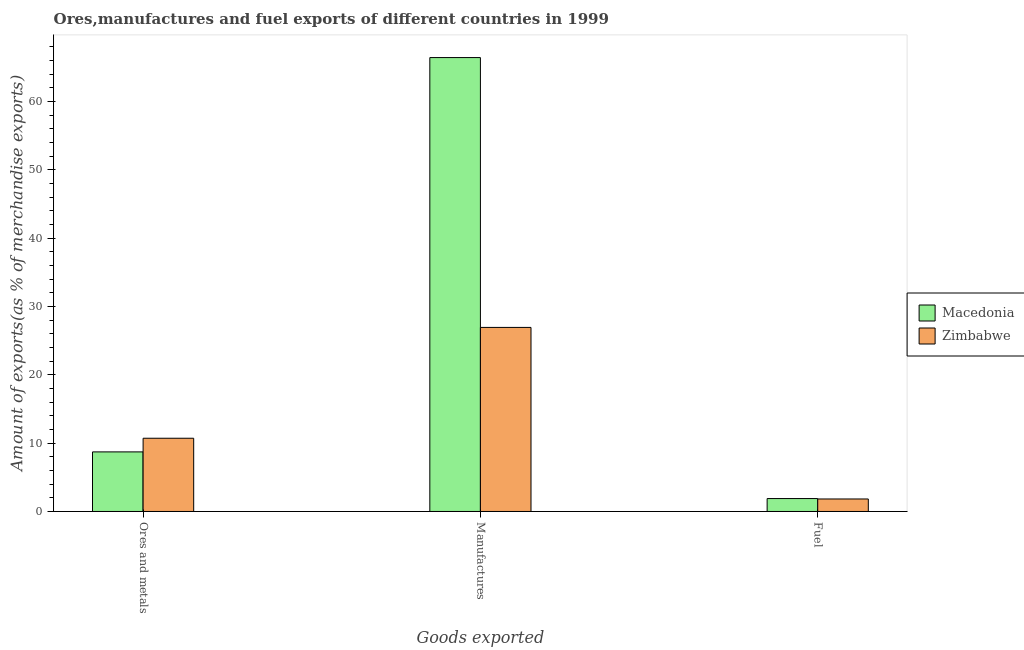How many different coloured bars are there?
Make the answer very short. 2. How many groups of bars are there?
Give a very brief answer. 3. Are the number of bars per tick equal to the number of legend labels?
Provide a short and direct response. Yes. How many bars are there on the 2nd tick from the left?
Offer a terse response. 2. How many bars are there on the 2nd tick from the right?
Provide a short and direct response. 2. What is the label of the 3rd group of bars from the left?
Provide a short and direct response. Fuel. What is the percentage of manufactures exports in Macedonia?
Provide a succinct answer. 66.43. Across all countries, what is the maximum percentage of fuel exports?
Ensure brevity in your answer.  1.89. Across all countries, what is the minimum percentage of manufactures exports?
Your answer should be very brief. 26.94. In which country was the percentage of manufactures exports maximum?
Your response must be concise. Macedonia. In which country was the percentage of manufactures exports minimum?
Your answer should be compact. Zimbabwe. What is the total percentage of fuel exports in the graph?
Your response must be concise. 3.72. What is the difference between the percentage of ores and metals exports in Macedonia and that in Zimbabwe?
Make the answer very short. -2. What is the difference between the percentage of ores and metals exports in Macedonia and the percentage of manufactures exports in Zimbabwe?
Provide a short and direct response. -18.22. What is the average percentage of fuel exports per country?
Offer a terse response. 1.86. What is the difference between the percentage of fuel exports and percentage of ores and metals exports in Zimbabwe?
Your answer should be compact. -8.89. What is the ratio of the percentage of ores and metals exports in Macedonia to that in Zimbabwe?
Provide a succinct answer. 0.81. Is the difference between the percentage of manufactures exports in Zimbabwe and Macedonia greater than the difference between the percentage of ores and metals exports in Zimbabwe and Macedonia?
Your answer should be compact. No. What is the difference between the highest and the second highest percentage of manufactures exports?
Provide a succinct answer. 39.49. What is the difference between the highest and the lowest percentage of ores and metals exports?
Provide a succinct answer. 2. What does the 1st bar from the left in Ores and metals represents?
Keep it short and to the point. Macedonia. What does the 2nd bar from the right in Manufactures represents?
Your answer should be very brief. Macedonia. Is it the case that in every country, the sum of the percentage of ores and metals exports and percentage of manufactures exports is greater than the percentage of fuel exports?
Give a very brief answer. Yes. How many bars are there?
Your answer should be compact. 6. Are all the bars in the graph horizontal?
Make the answer very short. No. What is the difference between two consecutive major ticks on the Y-axis?
Your answer should be very brief. 10. Are the values on the major ticks of Y-axis written in scientific E-notation?
Your answer should be compact. No. Does the graph contain grids?
Offer a terse response. No. How many legend labels are there?
Make the answer very short. 2. What is the title of the graph?
Your answer should be very brief. Ores,manufactures and fuel exports of different countries in 1999. What is the label or title of the X-axis?
Make the answer very short. Goods exported. What is the label or title of the Y-axis?
Provide a succinct answer. Amount of exports(as % of merchandise exports). What is the Amount of exports(as % of merchandise exports) in Macedonia in Ores and metals?
Provide a short and direct response. 8.72. What is the Amount of exports(as % of merchandise exports) of Zimbabwe in Ores and metals?
Provide a succinct answer. 10.72. What is the Amount of exports(as % of merchandise exports) of Macedonia in Manufactures?
Make the answer very short. 66.43. What is the Amount of exports(as % of merchandise exports) of Zimbabwe in Manufactures?
Offer a very short reply. 26.94. What is the Amount of exports(as % of merchandise exports) in Macedonia in Fuel?
Your answer should be compact. 1.89. What is the Amount of exports(as % of merchandise exports) in Zimbabwe in Fuel?
Offer a terse response. 1.83. Across all Goods exported, what is the maximum Amount of exports(as % of merchandise exports) of Macedonia?
Offer a terse response. 66.43. Across all Goods exported, what is the maximum Amount of exports(as % of merchandise exports) in Zimbabwe?
Ensure brevity in your answer.  26.94. Across all Goods exported, what is the minimum Amount of exports(as % of merchandise exports) of Macedonia?
Your answer should be compact. 1.89. Across all Goods exported, what is the minimum Amount of exports(as % of merchandise exports) in Zimbabwe?
Your response must be concise. 1.83. What is the total Amount of exports(as % of merchandise exports) of Macedonia in the graph?
Provide a short and direct response. 77.04. What is the total Amount of exports(as % of merchandise exports) in Zimbabwe in the graph?
Offer a very short reply. 39.49. What is the difference between the Amount of exports(as % of merchandise exports) of Macedonia in Ores and metals and that in Manufactures?
Offer a terse response. -57.71. What is the difference between the Amount of exports(as % of merchandise exports) of Zimbabwe in Ores and metals and that in Manufactures?
Your answer should be very brief. -16.22. What is the difference between the Amount of exports(as % of merchandise exports) in Macedonia in Ores and metals and that in Fuel?
Your answer should be very brief. 6.83. What is the difference between the Amount of exports(as % of merchandise exports) of Zimbabwe in Ores and metals and that in Fuel?
Your answer should be compact. 8.89. What is the difference between the Amount of exports(as % of merchandise exports) of Macedonia in Manufactures and that in Fuel?
Keep it short and to the point. 64.54. What is the difference between the Amount of exports(as % of merchandise exports) of Zimbabwe in Manufactures and that in Fuel?
Keep it short and to the point. 25.11. What is the difference between the Amount of exports(as % of merchandise exports) of Macedonia in Ores and metals and the Amount of exports(as % of merchandise exports) of Zimbabwe in Manufactures?
Provide a short and direct response. -18.22. What is the difference between the Amount of exports(as % of merchandise exports) in Macedonia in Ores and metals and the Amount of exports(as % of merchandise exports) in Zimbabwe in Fuel?
Provide a short and direct response. 6.89. What is the difference between the Amount of exports(as % of merchandise exports) of Macedonia in Manufactures and the Amount of exports(as % of merchandise exports) of Zimbabwe in Fuel?
Provide a short and direct response. 64.6. What is the average Amount of exports(as % of merchandise exports) in Macedonia per Goods exported?
Make the answer very short. 25.68. What is the average Amount of exports(as % of merchandise exports) in Zimbabwe per Goods exported?
Make the answer very short. 13.16. What is the difference between the Amount of exports(as % of merchandise exports) in Macedonia and Amount of exports(as % of merchandise exports) in Zimbabwe in Ores and metals?
Provide a succinct answer. -2. What is the difference between the Amount of exports(as % of merchandise exports) in Macedonia and Amount of exports(as % of merchandise exports) in Zimbabwe in Manufactures?
Make the answer very short. 39.49. What is the difference between the Amount of exports(as % of merchandise exports) of Macedonia and Amount of exports(as % of merchandise exports) of Zimbabwe in Fuel?
Keep it short and to the point. 0.06. What is the ratio of the Amount of exports(as % of merchandise exports) of Macedonia in Ores and metals to that in Manufactures?
Make the answer very short. 0.13. What is the ratio of the Amount of exports(as % of merchandise exports) in Zimbabwe in Ores and metals to that in Manufactures?
Keep it short and to the point. 0.4. What is the ratio of the Amount of exports(as % of merchandise exports) of Macedonia in Ores and metals to that in Fuel?
Offer a very short reply. 4.61. What is the ratio of the Amount of exports(as % of merchandise exports) of Zimbabwe in Ores and metals to that in Fuel?
Offer a very short reply. 5.85. What is the ratio of the Amount of exports(as % of merchandise exports) in Macedonia in Manufactures to that in Fuel?
Offer a very short reply. 35.09. What is the ratio of the Amount of exports(as % of merchandise exports) of Zimbabwe in Manufactures to that in Fuel?
Provide a succinct answer. 14.71. What is the difference between the highest and the second highest Amount of exports(as % of merchandise exports) in Macedonia?
Your response must be concise. 57.71. What is the difference between the highest and the second highest Amount of exports(as % of merchandise exports) in Zimbabwe?
Your response must be concise. 16.22. What is the difference between the highest and the lowest Amount of exports(as % of merchandise exports) of Macedonia?
Your answer should be compact. 64.54. What is the difference between the highest and the lowest Amount of exports(as % of merchandise exports) in Zimbabwe?
Offer a very short reply. 25.11. 